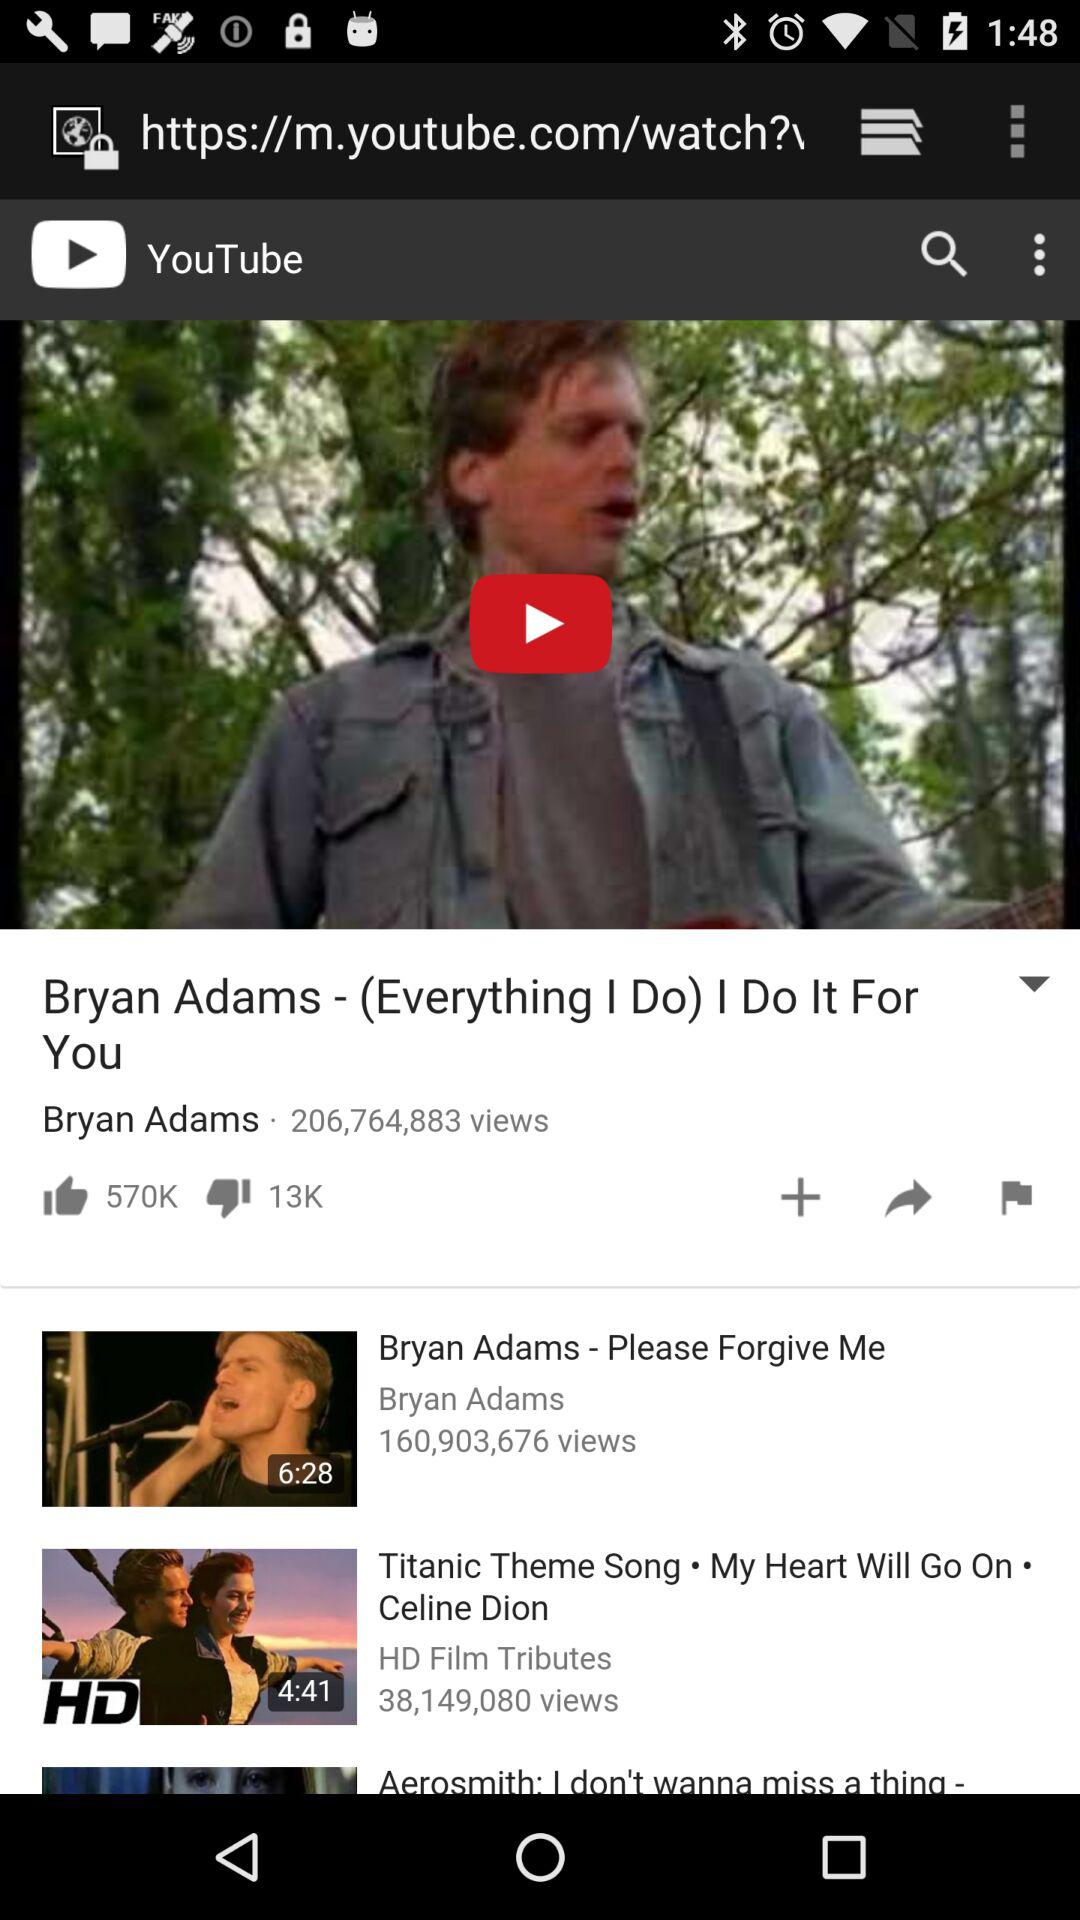How many thumbs up does the first video have?
Answer the question using a single word or phrase. 570K 